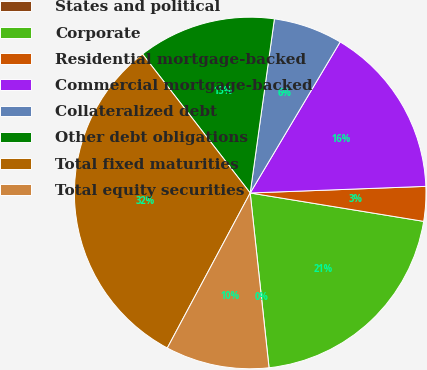<chart> <loc_0><loc_0><loc_500><loc_500><pie_chart><fcel>States and political<fcel>Corporate<fcel>Residential mortgage-backed<fcel>Commercial mortgage-backed<fcel>Collateralized debt<fcel>Other debt obligations<fcel>Total fixed maturities<fcel>Total equity securities<nl><fcel>0.01%<fcel>20.7%<fcel>3.18%<fcel>15.85%<fcel>6.35%<fcel>12.69%<fcel>31.69%<fcel>9.52%<nl></chart> 